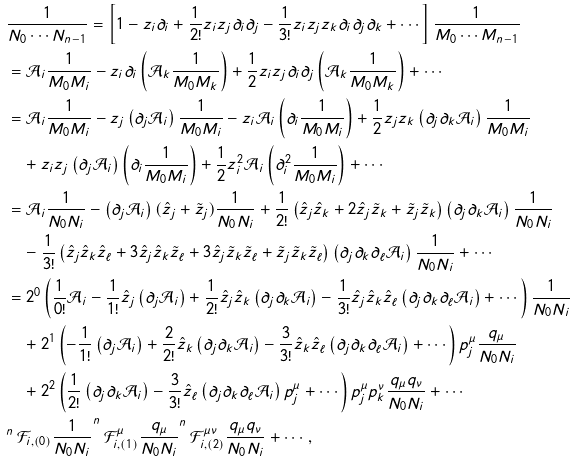Convert formula to latex. <formula><loc_0><loc_0><loc_500><loc_500>& \frac { 1 } { N _ { 0 } \cdots N _ { n - 1 } } = \left [ 1 - z _ { i } \partial _ { i } + \frac { 1 } { 2 ! } z _ { i } z _ { j } \partial _ { i } \partial _ { j } - \frac { 1 } { 3 ! } z _ { i } z _ { j } z _ { k } \partial _ { i } \partial _ { j } \partial _ { k } + \cdots \right ] \frac { 1 } { M _ { 0 } \cdots M _ { n - 1 } } \\ & = \mathcal { A } _ { i } \frac { 1 } { M _ { 0 } M _ { i } } - z _ { i } \partial _ { i } \left ( \mathcal { A } _ { k } \frac { 1 } { M _ { 0 } M _ { k } } \right ) + \frac { 1 } { 2 } z _ { i } z _ { j } \partial _ { i } \partial _ { j } \left ( \mathcal { A } _ { k } \frac { 1 } { M _ { 0 } M _ { k } } \right ) + \cdots \\ & = \mathcal { A } _ { i } \frac { 1 } { M _ { 0 } M _ { i } } - z _ { j } \left ( \partial _ { j } \mathcal { A } _ { i } \right ) \frac { 1 } { M _ { 0 } M _ { i } } - z _ { i } \mathcal { A } _ { i } \left ( \partial _ { i } \frac { 1 } { M _ { 0 } M _ { i } } \right ) + \frac { 1 } { 2 } z _ { j } z _ { k } \left ( \partial _ { j } \partial _ { k } \mathcal { A } _ { i } \right ) \frac { 1 } { M _ { 0 } M _ { i } } \\ & \quad + z _ { i } z _ { j } \left ( \partial _ { j } \mathcal { A } _ { i } \right ) \left ( \partial _ { i } \frac { 1 } { M _ { 0 } M _ { i } } \right ) + \frac { 1 } { 2 } z _ { i } ^ { 2 } \mathcal { A } _ { i } \left ( \partial _ { i } ^ { 2 } \frac { 1 } { M _ { 0 } M _ { i } } \right ) + \cdots \\ & = \mathcal { A } _ { i } \frac { 1 } { N _ { 0 } N _ { i } } - \left ( \partial _ { j } \mathcal { A } _ { i } \right ) ( \hat { z } _ { j } + \tilde { z } _ { j } ) \frac { 1 } { N _ { 0 } N _ { i } } + \frac { 1 } { 2 ! } \left ( \hat { z } _ { j } \hat { z } _ { k } + 2 \hat { z } _ { j } \tilde { z } _ { k } + \tilde { z } _ { j } \tilde { z } _ { k } \right ) \left ( \partial _ { j } \partial _ { k } \mathcal { A } _ { i } \right ) \frac { 1 } { N _ { 0 } N _ { i } } \\ & \quad - \frac { 1 } { 3 ! } \left ( \hat { z } _ { j } \hat { z } _ { k } \hat { z } _ { \ell } + 3 \hat { z } _ { j } \hat { z } _ { k } \tilde { z } _ { \ell } + 3 \hat { z } _ { j } \tilde { z } _ { k } \tilde { z } _ { \ell } + \tilde { z } _ { j } \tilde { z } _ { k } \tilde { z } _ { \ell } \right ) \left ( \partial _ { j } \partial _ { k } \partial _ { \ell } \mathcal { A } _ { i } \right ) \frac { 1 } { N _ { 0 } N _ { i } } + \cdots \\ & = 2 ^ { 0 } \left ( \frac { 1 } { 0 ! } \mathcal { A } _ { i } - \frac { 1 } { 1 ! } \hat { z } _ { j } \left ( \partial _ { j } \mathcal { A } _ { i } \right ) + \frac { 1 } { 2 ! } \hat { z } _ { j } \hat { z } _ { k } \left ( \partial _ { j } \partial _ { k } \mathcal { A } _ { i } \right ) - \frac { 1 } { 3 ! } \hat { z } _ { j } \hat { z } _ { k } \hat { z } _ { \ell } \left ( \partial _ { j } \partial _ { k } \partial _ { \ell } \mathcal { A } _ { i } \right ) + \cdots \right ) \frac { 1 } { N _ { 0 } N _ { i } } \\ & \quad + 2 ^ { 1 } \left ( - \frac { 1 } { 1 ! } \left ( \partial _ { j } \mathcal { A } _ { i } \right ) + \frac { 2 } { 2 ! } \hat { z } _ { k } \left ( \partial _ { j } \partial _ { k } \mathcal { A } _ { i } \right ) - \frac { 3 } { 3 ! } \hat { z } _ { k } \hat { z } _ { \ell } \left ( \partial _ { j } \partial _ { k } \partial _ { \ell } \mathcal { A } _ { i } \right ) + \cdots \right ) p _ { j } ^ { \mu } \frac { q _ { \mu } } { N _ { 0 } N _ { i } } \\ & \quad + 2 ^ { 2 } \left ( \frac { 1 } { 2 ! } \left ( \partial _ { j } \partial _ { k } \mathcal { A } _ { i } \right ) - \frac { 3 } { 3 ! } \hat { z } _ { \ell } \left ( \partial _ { j } \partial _ { k } \partial _ { \ell } \mathcal { A } _ { i } \right ) p _ { j } ^ { \mu } + \cdots \right ) p _ { j } ^ { \mu } p _ { k } ^ { \nu } \frac { q _ { \mu } q _ { \nu } } { N _ { 0 } N _ { i } } + \cdots \\ & ^ { n } \, \mathcal { F } _ { i , ( 0 ) } \frac { 1 } { N _ { 0 } N _ { i } } ^ { n } \, \mathcal { F } _ { i , ( 1 ) } ^ { \mu } \frac { q _ { \mu } } { N _ { 0 } N _ { i } } ^ { n } \, \mathcal { F } _ { i , ( 2 ) } ^ { \mu \nu } \frac { q _ { \mu } q _ { \nu } } { N _ { 0 } N _ { i } } + \cdots \, ,</formula> 